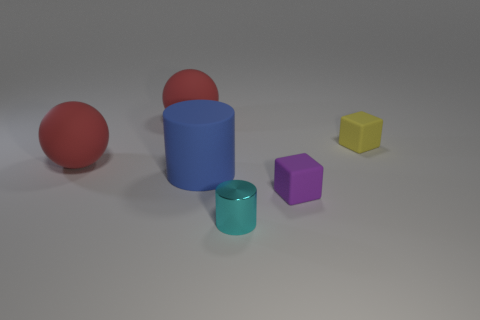Add 1 big rubber cylinders. How many objects exist? 7 Subtract all balls. How many objects are left? 4 Add 5 tiny rubber blocks. How many tiny rubber blocks exist? 7 Subtract 0 cyan cubes. How many objects are left? 6 Subtract all large blue blocks. Subtract all yellow objects. How many objects are left? 5 Add 5 small cyan cylinders. How many small cyan cylinders are left? 6 